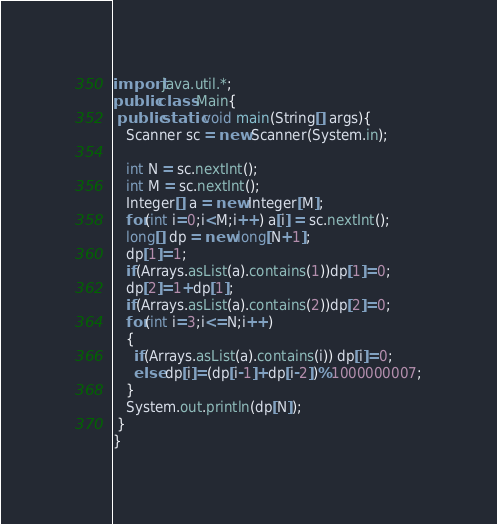Convert code to text. <code><loc_0><loc_0><loc_500><loc_500><_Java_>import java.util.*;
public class Main{
 public static void main(String[] args){
   Scanner sc = new Scanner(System.in);
 
   int N = sc.nextInt();
   int M = sc.nextInt();
   Integer[] a = new Integer[M];
   for(int i=0;i<M;i++) a[i] = sc.nextInt();
   long[] dp = new long[N+1];
   dp[1]=1;
   if(Arrays.asList(a).contains(1))dp[1]=0;
   dp[2]=1+dp[1];
   if(Arrays.asList(a).contains(2))dp[2]=0;
   for(int i=3;i<=N;i++)
   {
     if(Arrays.asList(a).contains(i)) dp[i]=0;
     else dp[i]=(dp[i-1]+dp[i-2])%1000000007;
   }
   System.out.println(dp[N]);
 }
}</code> 